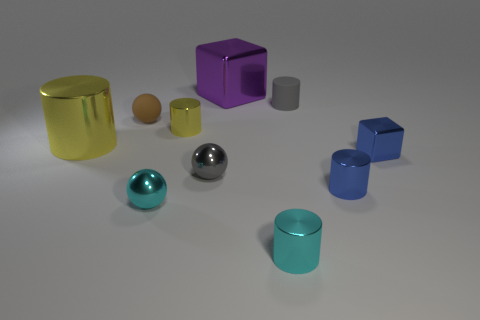The small rubber object that is right of the tiny gray object on the left side of the purple block is what shape?
Provide a succinct answer. Cylinder. Are there any other things that are the same color as the rubber ball?
Provide a short and direct response. No. Is the large metallic cylinder the same color as the rubber cylinder?
Ensure brevity in your answer.  No. What number of gray things are tiny rubber balls or big objects?
Offer a terse response. 0. Are there fewer blue metal cylinders that are behind the large purple cube than purple metal objects?
Give a very brief answer. Yes. How many small yellow shiny cylinders are on the right side of the rubber thing right of the large purple metallic thing?
Offer a very short reply. 0. How many other objects are there of the same size as the blue metal cube?
Keep it short and to the point. 7. What number of things are cyan rubber balls or tiny cyan objects that are on the right side of the purple block?
Ensure brevity in your answer.  1. Is the number of brown spheres less than the number of small gray rubber spheres?
Provide a succinct answer. No. What color is the large object that is behind the tiny sphere behind the tiny cube?
Your response must be concise. Purple. 